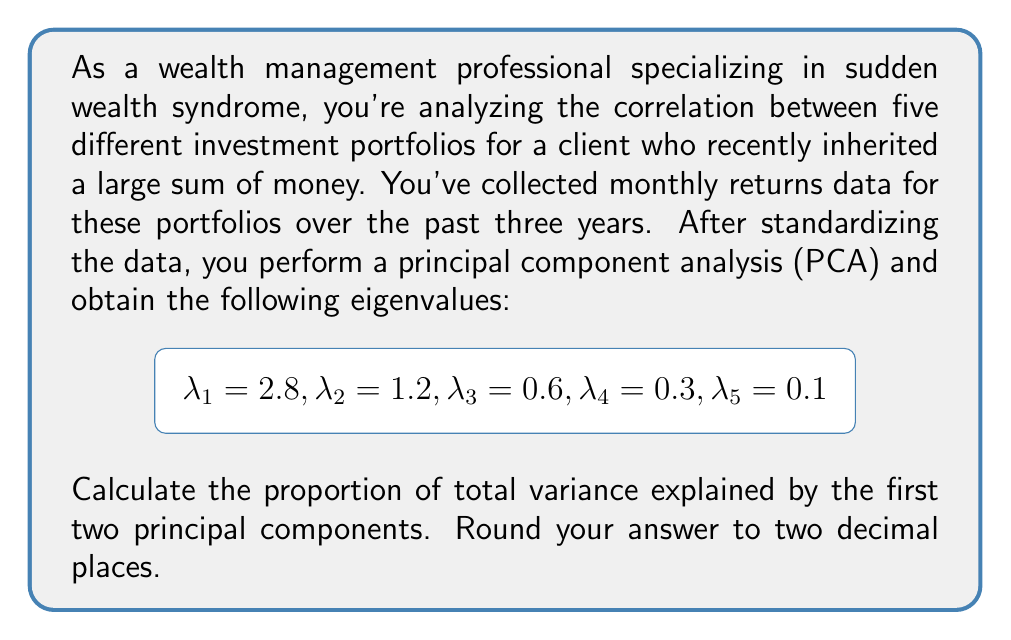Show me your answer to this math problem. To solve this problem, we'll follow these steps:

1) First, recall that in PCA, the total variance is equal to the sum of all eigenvalues.

2) Calculate the total variance:
   $$\text{Total Variance} = \sum_{i=1}^5 \lambda_i = 2.8 + 1.2 + 0.6 + 0.3 + 0.1 = 5$$

3) The variance explained by each principal component is proportional to its eigenvalue.

4) Calculate the proportion of variance explained by the first two principal components:
   
   For the first principal component:
   $$\frac{\lambda_1}{\text{Total Variance}} = \frac{2.8}{5} = 0.56$$

   For the second principal component:
   $$\frac{\lambda_2}{\text{Total Variance}} = \frac{1.2}{5} = 0.24$$

5) Sum these proportions:
   $$0.56 + 0.24 = 0.80$$

6) Convert to a percentage and round to two decimal places:
   $$0.80 * 100 = 80.00\%$$

Therefore, the first two principal components explain 80.00% of the total variance in the investment portfolio returns.
Answer: 80.00% 